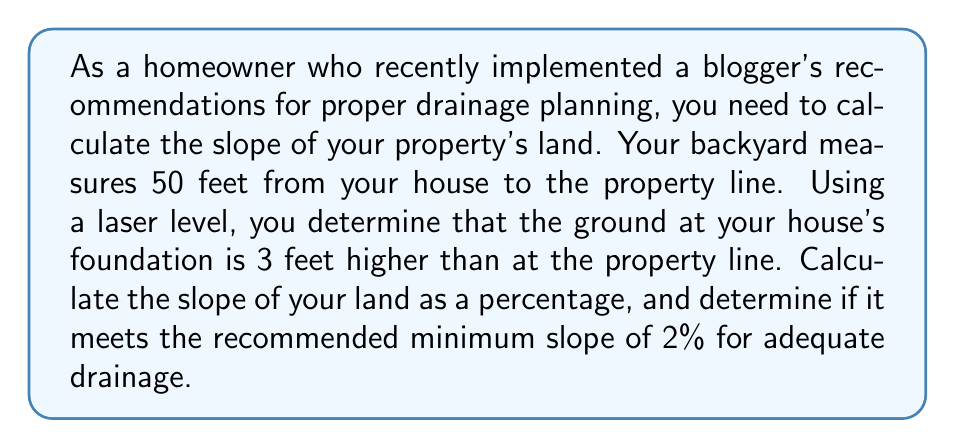Could you help me with this problem? To solve this problem, we'll follow these steps:

1. Calculate the slope using the rise-over-run formula:
   $$ \text{Slope} = \frac{\text{Rise}}{\text{Run}} $$

2. Convert the slope to a percentage:
   $$ \text{Slope percentage} = \text{Slope} \times 100\% $$

3. Compare the result to the recommended minimum slope.

Step 1: Calculate the slope
- Rise = 3 feet (elevation difference)
- Run = 50 feet (distance from house to property line)

$$ \text{Slope} = \frac{3 \text{ feet}}{50 \text{ feet}} = 0.06 $$

Step 2: Convert to percentage
$$ \text{Slope percentage} = 0.06 \times 100\% = 6\% $$

Step 3: Compare to recommended minimum
The calculated slope (6%) is greater than the recommended minimum slope of 2%, indicating that the property has adequate slope for proper drainage.

[asy]
unitsize(4mm);
draw((0,0)--(50,0), arrow=Arrow(TeXHead));
draw((0,0)--(0,3), arrow=Arrow(TeXHead));
draw((0,0)--(50,3));
label("50 feet", (25,-1));
label("3 feet", (-1,1.5));
label("House", (0,3.5));
label("Property line", (50,3.5));
[/asy]
Answer: The slope of the property's land is 6%, which exceeds the recommended minimum slope of 2% for adequate drainage. 